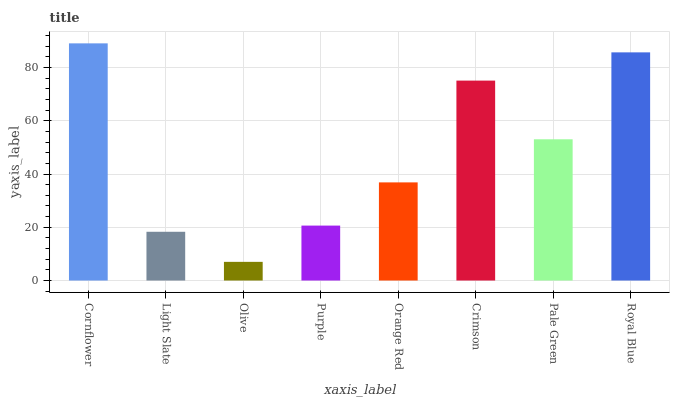Is Olive the minimum?
Answer yes or no. Yes. Is Cornflower the maximum?
Answer yes or no. Yes. Is Light Slate the minimum?
Answer yes or no. No. Is Light Slate the maximum?
Answer yes or no. No. Is Cornflower greater than Light Slate?
Answer yes or no. Yes. Is Light Slate less than Cornflower?
Answer yes or no. Yes. Is Light Slate greater than Cornflower?
Answer yes or no. No. Is Cornflower less than Light Slate?
Answer yes or no. No. Is Pale Green the high median?
Answer yes or no. Yes. Is Orange Red the low median?
Answer yes or no. Yes. Is Light Slate the high median?
Answer yes or no. No. Is Purple the low median?
Answer yes or no. No. 